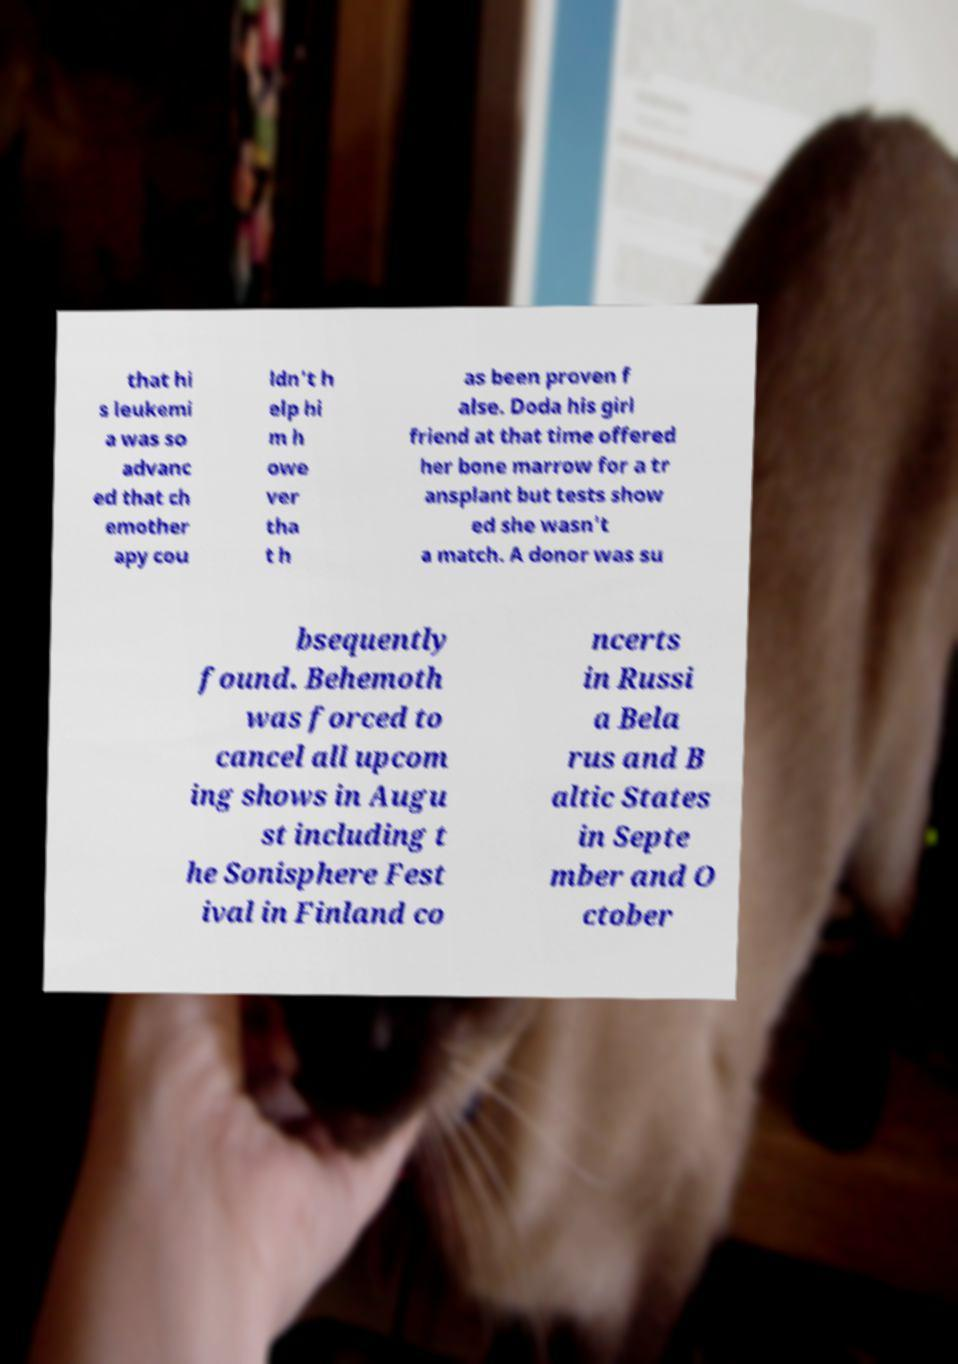Could you extract and type out the text from this image? that hi s leukemi a was so advanc ed that ch emother apy cou ldn't h elp hi m h owe ver tha t h as been proven f alse. Doda his girl friend at that time offered her bone marrow for a tr ansplant but tests show ed she wasn't a match. A donor was su bsequently found. Behemoth was forced to cancel all upcom ing shows in Augu st including t he Sonisphere Fest ival in Finland co ncerts in Russi a Bela rus and B altic States in Septe mber and O ctober 